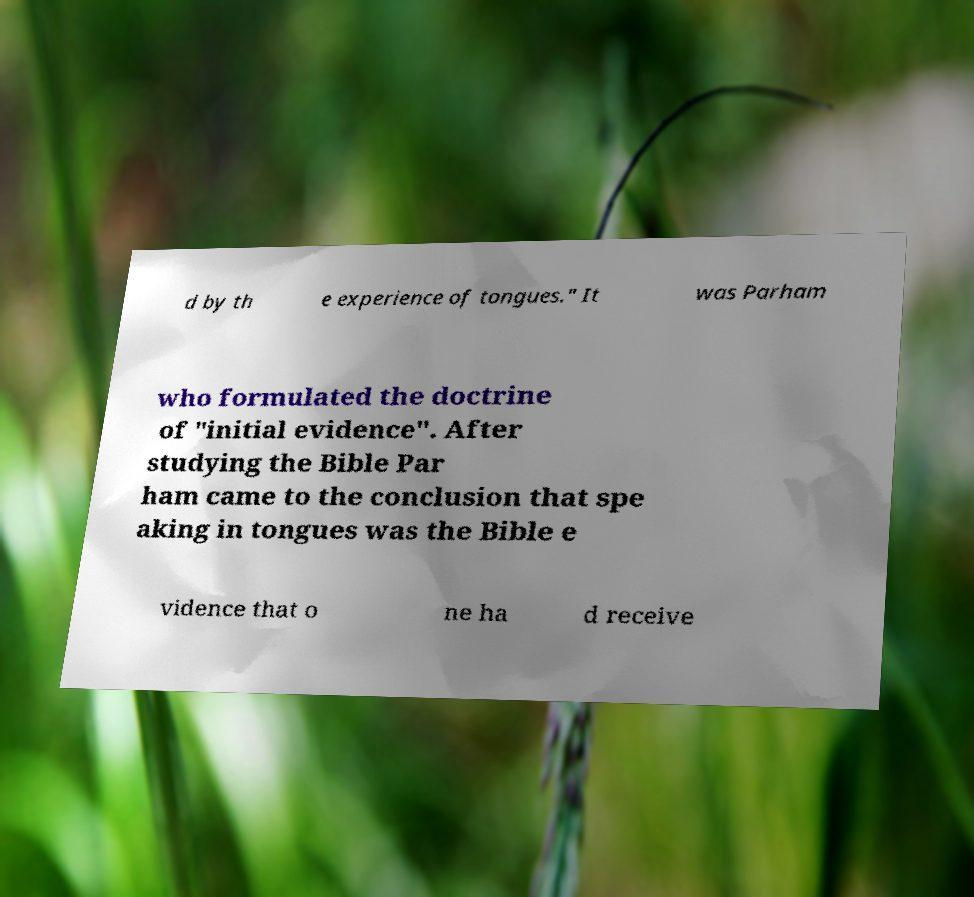There's text embedded in this image that I need extracted. Can you transcribe it verbatim? d by th e experience of tongues." It was Parham who formulated the doctrine of "initial evidence". After studying the Bible Par ham came to the conclusion that spe aking in tongues was the Bible e vidence that o ne ha d receive 